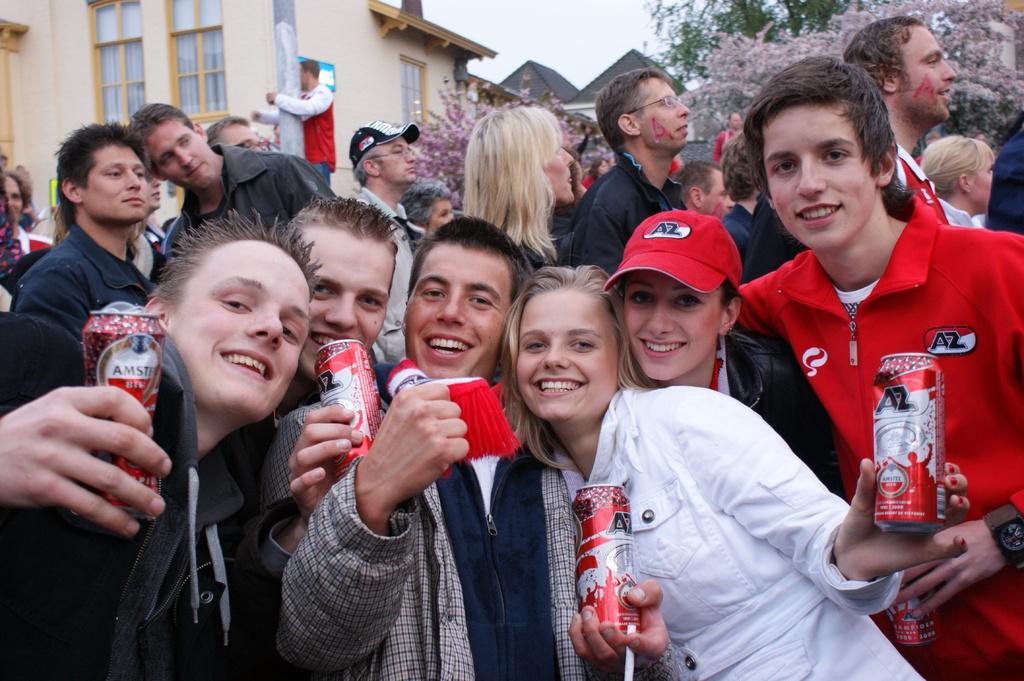Can you describe this image briefly? This is an outside view. Hear I can see few people are holding cock tins in their hands, smiling and giving pose for the picture. At the back of these people I can see some more people are standing and everyone is looking at the right side. In the background there are some trees and buildings and also I can see a person is holding a pole and standing. On the top of the image I can see the sky. 